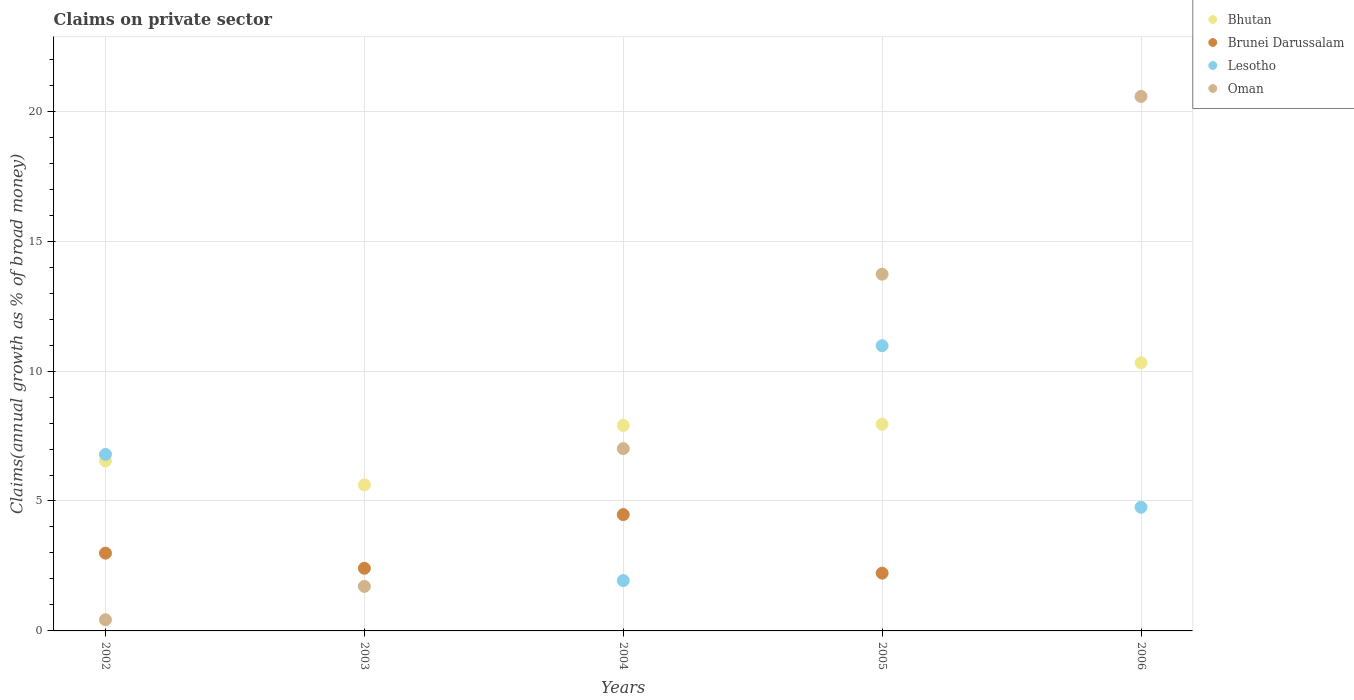What is the percentage of broad money claimed on private sector in Brunei Darussalam in 2002?
Your answer should be very brief. 2.99. Across all years, what is the maximum percentage of broad money claimed on private sector in Bhutan?
Your answer should be very brief. 10.32. Across all years, what is the minimum percentage of broad money claimed on private sector in Oman?
Your answer should be compact. 0.43. In which year was the percentage of broad money claimed on private sector in Oman maximum?
Provide a succinct answer. 2006. What is the total percentage of broad money claimed on private sector in Lesotho in the graph?
Offer a terse response. 24.47. What is the difference between the percentage of broad money claimed on private sector in Oman in 2002 and that in 2005?
Your answer should be compact. -13.3. What is the difference between the percentage of broad money claimed on private sector in Bhutan in 2002 and the percentage of broad money claimed on private sector in Lesotho in 2003?
Keep it short and to the point. 6.54. What is the average percentage of broad money claimed on private sector in Lesotho per year?
Offer a very short reply. 4.89. In the year 2002, what is the difference between the percentage of broad money claimed on private sector in Oman and percentage of broad money claimed on private sector in Brunei Darussalam?
Your answer should be compact. -2.56. In how many years, is the percentage of broad money claimed on private sector in Bhutan greater than 6 %?
Give a very brief answer. 4. What is the ratio of the percentage of broad money claimed on private sector in Lesotho in 2002 to that in 2006?
Ensure brevity in your answer.  1.43. Is the percentage of broad money claimed on private sector in Oman in 2002 less than that in 2005?
Provide a short and direct response. Yes. Is the difference between the percentage of broad money claimed on private sector in Oman in 2002 and 2004 greater than the difference between the percentage of broad money claimed on private sector in Brunei Darussalam in 2002 and 2004?
Provide a short and direct response. No. What is the difference between the highest and the second highest percentage of broad money claimed on private sector in Brunei Darussalam?
Make the answer very short. 1.48. What is the difference between the highest and the lowest percentage of broad money claimed on private sector in Bhutan?
Give a very brief answer. 4.7. Is the sum of the percentage of broad money claimed on private sector in Oman in 2002 and 2004 greater than the maximum percentage of broad money claimed on private sector in Lesotho across all years?
Your answer should be very brief. No. Is it the case that in every year, the sum of the percentage of broad money claimed on private sector in Lesotho and percentage of broad money claimed on private sector in Bhutan  is greater than the sum of percentage of broad money claimed on private sector in Oman and percentage of broad money claimed on private sector in Brunei Darussalam?
Offer a very short reply. No. Is it the case that in every year, the sum of the percentage of broad money claimed on private sector in Oman and percentage of broad money claimed on private sector in Brunei Darussalam  is greater than the percentage of broad money claimed on private sector in Bhutan?
Keep it short and to the point. No. Does the percentage of broad money claimed on private sector in Brunei Darussalam monotonically increase over the years?
Give a very brief answer. No. Is the percentage of broad money claimed on private sector in Oman strictly greater than the percentage of broad money claimed on private sector in Brunei Darussalam over the years?
Provide a succinct answer. No. Is the percentage of broad money claimed on private sector in Bhutan strictly less than the percentage of broad money claimed on private sector in Lesotho over the years?
Your response must be concise. No. How many years are there in the graph?
Make the answer very short. 5. What is the difference between two consecutive major ticks on the Y-axis?
Provide a short and direct response. 5. Are the values on the major ticks of Y-axis written in scientific E-notation?
Offer a very short reply. No. Does the graph contain any zero values?
Provide a short and direct response. Yes. How are the legend labels stacked?
Keep it short and to the point. Vertical. What is the title of the graph?
Offer a very short reply. Claims on private sector. What is the label or title of the X-axis?
Keep it short and to the point. Years. What is the label or title of the Y-axis?
Provide a short and direct response. Claims(annual growth as % of broad money). What is the Claims(annual growth as % of broad money) in Bhutan in 2002?
Your answer should be very brief. 6.54. What is the Claims(annual growth as % of broad money) of Brunei Darussalam in 2002?
Keep it short and to the point. 2.99. What is the Claims(annual growth as % of broad money) of Lesotho in 2002?
Your answer should be very brief. 6.79. What is the Claims(annual growth as % of broad money) of Oman in 2002?
Offer a terse response. 0.43. What is the Claims(annual growth as % of broad money) in Bhutan in 2003?
Offer a terse response. 5.62. What is the Claims(annual growth as % of broad money) in Brunei Darussalam in 2003?
Make the answer very short. 2.41. What is the Claims(annual growth as % of broad money) of Lesotho in 2003?
Provide a succinct answer. 0. What is the Claims(annual growth as % of broad money) of Oman in 2003?
Ensure brevity in your answer.  1.71. What is the Claims(annual growth as % of broad money) of Bhutan in 2004?
Offer a terse response. 7.91. What is the Claims(annual growth as % of broad money) in Brunei Darussalam in 2004?
Offer a very short reply. 4.48. What is the Claims(annual growth as % of broad money) in Lesotho in 2004?
Ensure brevity in your answer.  1.94. What is the Claims(annual growth as % of broad money) in Oman in 2004?
Your response must be concise. 7.02. What is the Claims(annual growth as % of broad money) of Bhutan in 2005?
Make the answer very short. 7.95. What is the Claims(annual growth as % of broad money) of Brunei Darussalam in 2005?
Keep it short and to the point. 2.22. What is the Claims(annual growth as % of broad money) in Lesotho in 2005?
Provide a short and direct response. 10.98. What is the Claims(annual growth as % of broad money) of Oman in 2005?
Offer a terse response. 13.73. What is the Claims(annual growth as % of broad money) in Bhutan in 2006?
Offer a terse response. 10.32. What is the Claims(annual growth as % of broad money) of Lesotho in 2006?
Provide a succinct answer. 4.76. What is the Claims(annual growth as % of broad money) of Oman in 2006?
Keep it short and to the point. 20.57. Across all years, what is the maximum Claims(annual growth as % of broad money) in Bhutan?
Provide a succinct answer. 10.32. Across all years, what is the maximum Claims(annual growth as % of broad money) in Brunei Darussalam?
Keep it short and to the point. 4.48. Across all years, what is the maximum Claims(annual growth as % of broad money) in Lesotho?
Give a very brief answer. 10.98. Across all years, what is the maximum Claims(annual growth as % of broad money) of Oman?
Ensure brevity in your answer.  20.57. Across all years, what is the minimum Claims(annual growth as % of broad money) of Bhutan?
Your response must be concise. 5.62. Across all years, what is the minimum Claims(annual growth as % of broad money) in Brunei Darussalam?
Provide a succinct answer. 0. Across all years, what is the minimum Claims(annual growth as % of broad money) of Oman?
Your response must be concise. 0.43. What is the total Claims(annual growth as % of broad money) in Bhutan in the graph?
Provide a short and direct response. 38.34. What is the total Claims(annual growth as % of broad money) of Brunei Darussalam in the graph?
Offer a very short reply. 12.1. What is the total Claims(annual growth as % of broad money) in Lesotho in the graph?
Give a very brief answer. 24.47. What is the total Claims(annual growth as % of broad money) in Oman in the graph?
Your response must be concise. 43.46. What is the difference between the Claims(annual growth as % of broad money) in Bhutan in 2002 and that in 2003?
Keep it short and to the point. 0.92. What is the difference between the Claims(annual growth as % of broad money) in Brunei Darussalam in 2002 and that in 2003?
Ensure brevity in your answer.  0.58. What is the difference between the Claims(annual growth as % of broad money) in Oman in 2002 and that in 2003?
Ensure brevity in your answer.  -1.28. What is the difference between the Claims(annual growth as % of broad money) of Bhutan in 2002 and that in 2004?
Offer a terse response. -1.36. What is the difference between the Claims(annual growth as % of broad money) of Brunei Darussalam in 2002 and that in 2004?
Provide a succinct answer. -1.48. What is the difference between the Claims(annual growth as % of broad money) of Lesotho in 2002 and that in 2004?
Make the answer very short. 4.86. What is the difference between the Claims(annual growth as % of broad money) in Oman in 2002 and that in 2004?
Ensure brevity in your answer.  -6.59. What is the difference between the Claims(annual growth as % of broad money) of Bhutan in 2002 and that in 2005?
Ensure brevity in your answer.  -1.41. What is the difference between the Claims(annual growth as % of broad money) in Brunei Darussalam in 2002 and that in 2005?
Give a very brief answer. 0.77. What is the difference between the Claims(annual growth as % of broad money) of Lesotho in 2002 and that in 2005?
Make the answer very short. -4.18. What is the difference between the Claims(annual growth as % of broad money) in Oman in 2002 and that in 2005?
Your response must be concise. -13.3. What is the difference between the Claims(annual growth as % of broad money) of Bhutan in 2002 and that in 2006?
Ensure brevity in your answer.  -3.77. What is the difference between the Claims(annual growth as % of broad money) in Lesotho in 2002 and that in 2006?
Offer a very short reply. 2.03. What is the difference between the Claims(annual growth as % of broad money) in Oman in 2002 and that in 2006?
Offer a very short reply. -20.14. What is the difference between the Claims(annual growth as % of broad money) in Bhutan in 2003 and that in 2004?
Provide a succinct answer. -2.29. What is the difference between the Claims(annual growth as % of broad money) in Brunei Darussalam in 2003 and that in 2004?
Ensure brevity in your answer.  -2.07. What is the difference between the Claims(annual growth as % of broad money) of Oman in 2003 and that in 2004?
Your answer should be compact. -5.3. What is the difference between the Claims(annual growth as % of broad money) in Bhutan in 2003 and that in 2005?
Your answer should be compact. -2.33. What is the difference between the Claims(annual growth as % of broad money) in Brunei Darussalam in 2003 and that in 2005?
Offer a very short reply. 0.19. What is the difference between the Claims(annual growth as % of broad money) of Oman in 2003 and that in 2005?
Provide a short and direct response. -12.01. What is the difference between the Claims(annual growth as % of broad money) in Bhutan in 2003 and that in 2006?
Provide a short and direct response. -4.7. What is the difference between the Claims(annual growth as % of broad money) in Oman in 2003 and that in 2006?
Give a very brief answer. -18.85. What is the difference between the Claims(annual growth as % of broad money) of Bhutan in 2004 and that in 2005?
Give a very brief answer. -0.05. What is the difference between the Claims(annual growth as % of broad money) in Brunei Darussalam in 2004 and that in 2005?
Ensure brevity in your answer.  2.25. What is the difference between the Claims(annual growth as % of broad money) of Lesotho in 2004 and that in 2005?
Make the answer very short. -9.04. What is the difference between the Claims(annual growth as % of broad money) of Oman in 2004 and that in 2005?
Offer a terse response. -6.71. What is the difference between the Claims(annual growth as % of broad money) in Bhutan in 2004 and that in 2006?
Give a very brief answer. -2.41. What is the difference between the Claims(annual growth as % of broad money) in Lesotho in 2004 and that in 2006?
Offer a very short reply. -2.82. What is the difference between the Claims(annual growth as % of broad money) in Oman in 2004 and that in 2006?
Your answer should be compact. -13.55. What is the difference between the Claims(annual growth as % of broad money) of Bhutan in 2005 and that in 2006?
Your answer should be compact. -2.36. What is the difference between the Claims(annual growth as % of broad money) of Lesotho in 2005 and that in 2006?
Your answer should be compact. 6.22. What is the difference between the Claims(annual growth as % of broad money) of Oman in 2005 and that in 2006?
Your answer should be very brief. -6.84. What is the difference between the Claims(annual growth as % of broad money) of Bhutan in 2002 and the Claims(annual growth as % of broad money) of Brunei Darussalam in 2003?
Give a very brief answer. 4.13. What is the difference between the Claims(annual growth as % of broad money) in Bhutan in 2002 and the Claims(annual growth as % of broad money) in Oman in 2003?
Provide a short and direct response. 4.83. What is the difference between the Claims(annual growth as % of broad money) in Brunei Darussalam in 2002 and the Claims(annual growth as % of broad money) in Oman in 2003?
Offer a terse response. 1.28. What is the difference between the Claims(annual growth as % of broad money) in Lesotho in 2002 and the Claims(annual growth as % of broad money) in Oman in 2003?
Offer a terse response. 5.08. What is the difference between the Claims(annual growth as % of broad money) of Bhutan in 2002 and the Claims(annual growth as % of broad money) of Brunei Darussalam in 2004?
Offer a terse response. 2.07. What is the difference between the Claims(annual growth as % of broad money) of Bhutan in 2002 and the Claims(annual growth as % of broad money) of Lesotho in 2004?
Offer a terse response. 4.61. What is the difference between the Claims(annual growth as % of broad money) of Bhutan in 2002 and the Claims(annual growth as % of broad money) of Oman in 2004?
Provide a succinct answer. -0.47. What is the difference between the Claims(annual growth as % of broad money) of Brunei Darussalam in 2002 and the Claims(annual growth as % of broad money) of Lesotho in 2004?
Make the answer very short. 1.06. What is the difference between the Claims(annual growth as % of broad money) of Brunei Darussalam in 2002 and the Claims(annual growth as % of broad money) of Oman in 2004?
Give a very brief answer. -4.02. What is the difference between the Claims(annual growth as % of broad money) in Lesotho in 2002 and the Claims(annual growth as % of broad money) in Oman in 2004?
Your answer should be compact. -0.22. What is the difference between the Claims(annual growth as % of broad money) in Bhutan in 2002 and the Claims(annual growth as % of broad money) in Brunei Darussalam in 2005?
Provide a short and direct response. 4.32. What is the difference between the Claims(annual growth as % of broad money) of Bhutan in 2002 and the Claims(annual growth as % of broad money) of Lesotho in 2005?
Ensure brevity in your answer.  -4.43. What is the difference between the Claims(annual growth as % of broad money) in Bhutan in 2002 and the Claims(annual growth as % of broad money) in Oman in 2005?
Keep it short and to the point. -7.18. What is the difference between the Claims(annual growth as % of broad money) in Brunei Darussalam in 2002 and the Claims(annual growth as % of broad money) in Lesotho in 2005?
Your response must be concise. -7.98. What is the difference between the Claims(annual growth as % of broad money) of Brunei Darussalam in 2002 and the Claims(annual growth as % of broad money) of Oman in 2005?
Give a very brief answer. -10.73. What is the difference between the Claims(annual growth as % of broad money) of Lesotho in 2002 and the Claims(annual growth as % of broad money) of Oman in 2005?
Make the answer very short. -6.94. What is the difference between the Claims(annual growth as % of broad money) in Bhutan in 2002 and the Claims(annual growth as % of broad money) in Lesotho in 2006?
Keep it short and to the point. 1.78. What is the difference between the Claims(annual growth as % of broad money) in Bhutan in 2002 and the Claims(annual growth as % of broad money) in Oman in 2006?
Keep it short and to the point. -14.02. What is the difference between the Claims(annual growth as % of broad money) in Brunei Darussalam in 2002 and the Claims(annual growth as % of broad money) in Lesotho in 2006?
Give a very brief answer. -1.77. What is the difference between the Claims(annual growth as % of broad money) of Brunei Darussalam in 2002 and the Claims(annual growth as % of broad money) of Oman in 2006?
Make the answer very short. -17.58. What is the difference between the Claims(annual growth as % of broad money) of Lesotho in 2002 and the Claims(annual growth as % of broad money) of Oman in 2006?
Make the answer very short. -13.78. What is the difference between the Claims(annual growth as % of broad money) of Bhutan in 2003 and the Claims(annual growth as % of broad money) of Brunei Darussalam in 2004?
Provide a succinct answer. 1.14. What is the difference between the Claims(annual growth as % of broad money) of Bhutan in 2003 and the Claims(annual growth as % of broad money) of Lesotho in 2004?
Offer a very short reply. 3.68. What is the difference between the Claims(annual growth as % of broad money) of Bhutan in 2003 and the Claims(annual growth as % of broad money) of Oman in 2004?
Provide a short and direct response. -1.4. What is the difference between the Claims(annual growth as % of broad money) in Brunei Darussalam in 2003 and the Claims(annual growth as % of broad money) in Lesotho in 2004?
Offer a very short reply. 0.47. What is the difference between the Claims(annual growth as % of broad money) in Brunei Darussalam in 2003 and the Claims(annual growth as % of broad money) in Oman in 2004?
Your answer should be very brief. -4.61. What is the difference between the Claims(annual growth as % of broad money) in Bhutan in 2003 and the Claims(annual growth as % of broad money) in Brunei Darussalam in 2005?
Your response must be concise. 3.4. What is the difference between the Claims(annual growth as % of broad money) of Bhutan in 2003 and the Claims(annual growth as % of broad money) of Lesotho in 2005?
Offer a very short reply. -5.36. What is the difference between the Claims(annual growth as % of broad money) of Bhutan in 2003 and the Claims(annual growth as % of broad money) of Oman in 2005?
Offer a terse response. -8.11. What is the difference between the Claims(annual growth as % of broad money) of Brunei Darussalam in 2003 and the Claims(annual growth as % of broad money) of Lesotho in 2005?
Your answer should be very brief. -8.57. What is the difference between the Claims(annual growth as % of broad money) in Brunei Darussalam in 2003 and the Claims(annual growth as % of broad money) in Oman in 2005?
Ensure brevity in your answer.  -11.32. What is the difference between the Claims(annual growth as % of broad money) in Bhutan in 2003 and the Claims(annual growth as % of broad money) in Lesotho in 2006?
Keep it short and to the point. 0.86. What is the difference between the Claims(annual growth as % of broad money) of Bhutan in 2003 and the Claims(annual growth as % of broad money) of Oman in 2006?
Ensure brevity in your answer.  -14.95. What is the difference between the Claims(annual growth as % of broad money) of Brunei Darussalam in 2003 and the Claims(annual growth as % of broad money) of Lesotho in 2006?
Give a very brief answer. -2.35. What is the difference between the Claims(annual growth as % of broad money) of Brunei Darussalam in 2003 and the Claims(annual growth as % of broad money) of Oman in 2006?
Offer a terse response. -18.16. What is the difference between the Claims(annual growth as % of broad money) in Bhutan in 2004 and the Claims(annual growth as % of broad money) in Brunei Darussalam in 2005?
Offer a terse response. 5.69. What is the difference between the Claims(annual growth as % of broad money) in Bhutan in 2004 and the Claims(annual growth as % of broad money) in Lesotho in 2005?
Make the answer very short. -3.07. What is the difference between the Claims(annual growth as % of broad money) in Bhutan in 2004 and the Claims(annual growth as % of broad money) in Oman in 2005?
Your answer should be compact. -5.82. What is the difference between the Claims(annual growth as % of broad money) of Brunei Darussalam in 2004 and the Claims(annual growth as % of broad money) of Lesotho in 2005?
Offer a terse response. -6.5. What is the difference between the Claims(annual growth as % of broad money) of Brunei Darussalam in 2004 and the Claims(annual growth as % of broad money) of Oman in 2005?
Provide a succinct answer. -9.25. What is the difference between the Claims(annual growth as % of broad money) in Lesotho in 2004 and the Claims(annual growth as % of broad money) in Oman in 2005?
Your answer should be very brief. -11.79. What is the difference between the Claims(annual growth as % of broad money) of Bhutan in 2004 and the Claims(annual growth as % of broad money) of Lesotho in 2006?
Offer a very short reply. 3.15. What is the difference between the Claims(annual growth as % of broad money) of Bhutan in 2004 and the Claims(annual growth as % of broad money) of Oman in 2006?
Offer a terse response. -12.66. What is the difference between the Claims(annual growth as % of broad money) of Brunei Darussalam in 2004 and the Claims(annual growth as % of broad money) of Lesotho in 2006?
Make the answer very short. -0.28. What is the difference between the Claims(annual growth as % of broad money) in Brunei Darussalam in 2004 and the Claims(annual growth as % of broad money) in Oman in 2006?
Give a very brief answer. -16.09. What is the difference between the Claims(annual growth as % of broad money) of Lesotho in 2004 and the Claims(annual growth as % of broad money) of Oman in 2006?
Give a very brief answer. -18.63. What is the difference between the Claims(annual growth as % of broad money) in Bhutan in 2005 and the Claims(annual growth as % of broad money) in Lesotho in 2006?
Provide a succinct answer. 3.19. What is the difference between the Claims(annual growth as % of broad money) of Bhutan in 2005 and the Claims(annual growth as % of broad money) of Oman in 2006?
Your answer should be compact. -12.62. What is the difference between the Claims(annual growth as % of broad money) in Brunei Darussalam in 2005 and the Claims(annual growth as % of broad money) in Lesotho in 2006?
Ensure brevity in your answer.  -2.54. What is the difference between the Claims(annual growth as % of broad money) in Brunei Darussalam in 2005 and the Claims(annual growth as % of broad money) in Oman in 2006?
Ensure brevity in your answer.  -18.35. What is the difference between the Claims(annual growth as % of broad money) in Lesotho in 2005 and the Claims(annual growth as % of broad money) in Oman in 2006?
Your answer should be compact. -9.59. What is the average Claims(annual growth as % of broad money) of Bhutan per year?
Provide a succinct answer. 7.67. What is the average Claims(annual growth as % of broad money) of Brunei Darussalam per year?
Your answer should be compact. 2.42. What is the average Claims(annual growth as % of broad money) in Lesotho per year?
Make the answer very short. 4.89. What is the average Claims(annual growth as % of broad money) of Oman per year?
Offer a very short reply. 8.69. In the year 2002, what is the difference between the Claims(annual growth as % of broad money) of Bhutan and Claims(annual growth as % of broad money) of Brunei Darussalam?
Ensure brevity in your answer.  3.55. In the year 2002, what is the difference between the Claims(annual growth as % of broad money) in Bhutan and Claims(annual growth as % of broad money) in Lesotho?
Offer a very short reply. -0.25. In the year 2002, what is the difference between the Claims(annual growth as % of broad money) of Bhutan and Claims(annual growth as % of broad money) of Oman?
Provide a short and direct response. 6.12. In the year 2002, what is the difference between the Claims(annual growth as % of broad money) in Brunei Darussalam and Claims(annual growth as % of broad money) in Lesotho?
Your response must be concise. -3.8. In the year 2002, what is the difference between the Claims(annual growth as % of broad money) in Brunei Darussalam and Claims(annual growth as % of broad money) in Oman?
Offer a very short reply. 2.56. In the year 2002, what is the difference between the Claims(annual growth as % of broad money) in Lesotho and Claims(annual growth as % of broad money) in Oman?
Offer a very short reply. 6.36. In the year 2003, what is the difference between the Claims(annual growth as % of broad money) in Bhutan and Claims(annual growth as % of broad money) in Brunei Darussalam?
Your response must be concise. 3.21. In the year 2003, what is the difference between the Claims(annual growth as % of broad money) of Bhutan and Claims(annual growth as % of broad money) of Oman?
Provide a succinct answer. 3.91. In the year 2003, what is the difference between the Claims(annual growth as % of broad money) in Brunei Darussalam and Claims(annual growth as % of broad money) in Oman?
Ensure brevity in your answer.  0.7. In the year 2004, what is the difference between the Claims(annual growth as % of broad money) of Bhutan and Claims(annual growth as % of broad money) of Brunei Darussalam?
Make the answer very short. 3.43. In the year 2004, what is the difference between the Claims(annual growth as % of broad money) in Bhutan and Claims(annual growth as % of broad money) in Lesotho?
Provide a short and direct response. 5.97. In the year 2004, what is the difference between the Claims(annual growth as % of broad money) of Bhutan and Claims(annual growth as % of broad money) of Oman?
Your answer should be very brief. 0.89. In the year 2004, what is the difference between the Claims(annual growth as % of broad money) in Brunei Darussalam and Claims(annual growth as % of broad money) in Lesotho?
Your answer should be compact. 2.54. In the year 2004, what is the difference between the Claims(annual growth as % of broad money) of Brunei Darussalam and Claims(annual growth as % of broad money) of Oman?
Provide a succinct answer. -2.54. In the year 2004, what is the difference between the Claims(annual growth as % of broad money) in Lesotho and Claims(annual growth as % of broad money) in Oman?
Offer a very short reply. -5.08. In the year 2005, what is the difference between the Claims(annual growth as % of broad money) of Bhutan and Claims(annual growth as % of broad money) of Brunei Darussalam?
Offer a terse response. 5.73. In the year 2005, what is the difference between the Claims(annual growth as % of broad money) in Bhutan and Claims(annual growth as % of broad money) in Lesotho?
Offer a very short reply. -3.02. In the year 2005, what is the difference between the Claims(annual growth as % of broad money) of Bhutan and Claims(annual growth as % of broad money) of Oman?
Your response must be concise. -5.77. In the year 2005, what is the difference between the Claims(annual growth as % of broad money) in Brunei Darussalam and Claims(annual growth as % of broad money) in Lesotho?
Ensure brevity in your answer.  -8.75. In the year 2005, what is the difference between the Claims(annual growth as % of broad money) of Brunei Darussalam and Claims(annual growth as % of broad money) of Oman?
Offer a very short reply. -11.5. In the year 2005, what is the difference between the Claims(annual growth as % of broad money) in Lesotho and Claims(annual growth as % of broad money) in Oman?
Provide a succinct answer. -2.75. In the year 2006, what is the difference between the Claims(annual growth as % of broad money) of Bhutan and Claims(annual growth as % of broad money) of Lesotho?
Your answer should be compact. 5.56. In the year 2006, what is the difference between the Claims(annual growth as % of broad money) of Bhutan and Claims(annual growth as % of broad money) of Oman?
Give a very brief answer. -10.25. In the year 2006, what is the difference between the Claims(annual growth as % of broad money) in Lesotho and Claims(annual growth as % of broad money) in Oman?
Offer a very short reply. -15.81. What is the ratio of the Claims(annual growth as % of broad money) in Bhutan in 2002 to that in 2003?
Make the answer very short. 1.16. What is the ratio of the Claims(annual growth as % of broad money) of Brunei Darussalam in 2002 to that in 2003?
Ensure brevity in your answer.  1.24. What is the ratio of the Claims(annual growth as % of broad money) in Oman in 2002 to that in 2003?
Make the answer very short. 0.25. What is the ratio of the Claims(annual growth as % of broad money) in Bhutan in 2002 to that in 2004?
Your answer should be very brief. 0.83. What is the ratio of the Claims(annual growth as % of broad money) of Brunei Darussalam in 2002 to that in 2004?
Ensure brevity in your answer.  0.67. What is the ratio of the Claims(annual growth as % of broad money) of Lesotho in 2002 to that in 2004?
Your answer should be very brief. 3.51. What is the ratio of the Claims(annual growth as % of broad money) of Oman in 2002 to that in 2004?
Ensure brevity in your answer.  0.06. What is the ratio of the Claims(annual growth as % of broad money) in Bhutan in 2002 to that in 2005?
Provide a short and direct response. 0.82. What is the ratio of the Claims(annual growth as % of broad money) of Brunei Darussalam in 2002 to that in 2005?
Your answer should be very brief. 1.35. What is the ratio of the Claims(annual growth as % of broad money) in Lesotho in 2002 to that in 2005?
Ensure brevity in your answer.  0.62. What is the ratio of the Claims(annual growth as % of broad money) in Oman in 2002 to that in 2005?
Offer a terse response. 0.03. What is the ratio of the Claims(annual growth as % of broad money) of Bhutan in 2002 to that in 2006?
Ensure brevity in your answer.  0.63. What is the ratio of the Claims(annual growth as % of broad money) of Lesotho in 2002 to that in 2006?
Ensure brevity in your answer.  1.43. What is the ratio of the Claims(annual growth as % of broad money) of Oman in 2002 to that in 2006?
Your response must be concise. 0.02. What is the ratio of the Claims(annual growth as % of broad money) of Bhutan in 2003 to that in 2004?
Offer a very short reply. 0.71. What is the ratio of the Claims(annual growth as % of broad money) in Brunei Darussalam in 2003 to that in 2004?
Give a very brief answer. 0.54. What is the ratio of the Claims(annual growth as % of broad money) of Oman in 2003 to that in 2004?
Your answer should be very brief. 0.24. What is the ratio of the Claims(annual growth as % of broad money) of Bhutan in 2003 to that in 2005?
Your answer should be compact. 0.71. What is the ratio of the Claims(annual growth as % of broad money) in Brunei Darussalam in 2003 to that in 2005?
Keep it short and to the point. 1.08. What is the ratio of the Claims(annual growth as % of broad money) of Oman in 2003 to that in 2005?
Offer a very short reply. 0.12. What is the ratio of the Claims(annual growth as % of broad money) of Bhutan in 2003 to that in 2006?
Provide a short and direct response. 0.54. What is the ratio of the Claims(annual growth as % of broad money) of Oman in 2003 to that in 2006?
Provide a short and direct response. 0.08. What is the ratio of the Claims(annual growth as % of broad money) of Bhutan in 2004 to that in 2005?
Provide a short and direct response. 0.99. What is the ratio of the Claims(annual growth as % of broad money) of Brunei Darussalam in 2004 to that in 2005?
Ensure brevity in your answer.  2.01. What is the ratio of the Claims(annual growth as % of broad money) in Lesotho in 2004 to that in 2005?
Offer a very short reply. 0.18. What is the ratio of the Claims(annual growth as % of broad money) of Oman in 2004 to that in 2005?
Offer a terse response. 0.51. What is the ratio of the Claims(annual growth as % of broad money) in Bhutan in 2004 to that in 2006?
Your answer should be very brief. 0.77. What is the ratio of the Claims(annual growth as % of broad money) of Lesotho in 2004 to that in 2006?
Your answer should be compact. 0.41. What is the ratio of the Claims(annual growth as % of broad money) in Oman in 2004 to that in 2006?
Offer a terse response. 0.34. What is the ratio of the Claims(annual growth as % of broad money) in Bhutan in 2005 to that in 2006?
Your answer should be compact. 0.77. What is the ratio of the Claims(annual growth as % of broad money) in Lesotho in 2005 to that in 2006?
Offer a terse response. 2.31. What is the ratio of the Claims(annual growth as % of broad money) of Oman in 2005 to that in 2006?
Provide a succinct answer. 0.67. What is the difference between the highest and the second highest Claims(annual growth as % of broad money) in Bhutan?
Your answer should be compact. 2.36. What is the difference between the highest and the second highest Claims(annual growth as % of broad money) in Brunei Darussalam?
Your answer should be compact. 1.48. What is the difference between the highest and the second highest Claims(annual growth as % of broad money) in Lesotho?
Your answer should be very brief. 4.18. What is the difference between the highest and the second highest Claims(annual growth as % of broad money) in Oman?
Your response must be concise. 6.84. What is the difference between the highest and the lowest Claims(annual growth as % of broad money) of Bhutan?
Keep it short and to the point. 4.7. What is the difference between the highest and the lowest Claims(annual growth as % of broad money) in Brunei Darussalam?
Give a very brief answer. 4.48. What is the difference between the highest and the lowest Claims(annual growth as % of broad money) of Lesotho?
Keep it short and to the point. 10.98. What is the difference between the highest and the lowest Claims(annual growth as % of broad money) in Oman?
Provide a succinct answer. 20.14. 